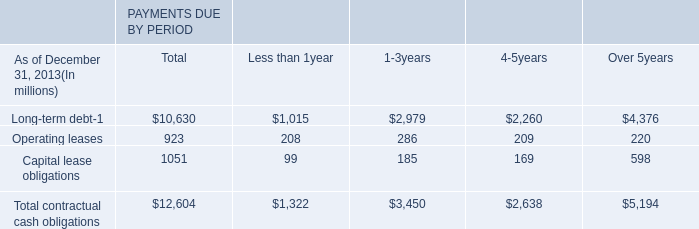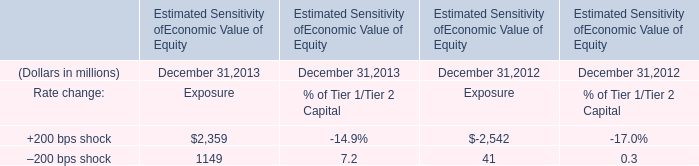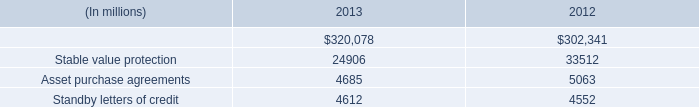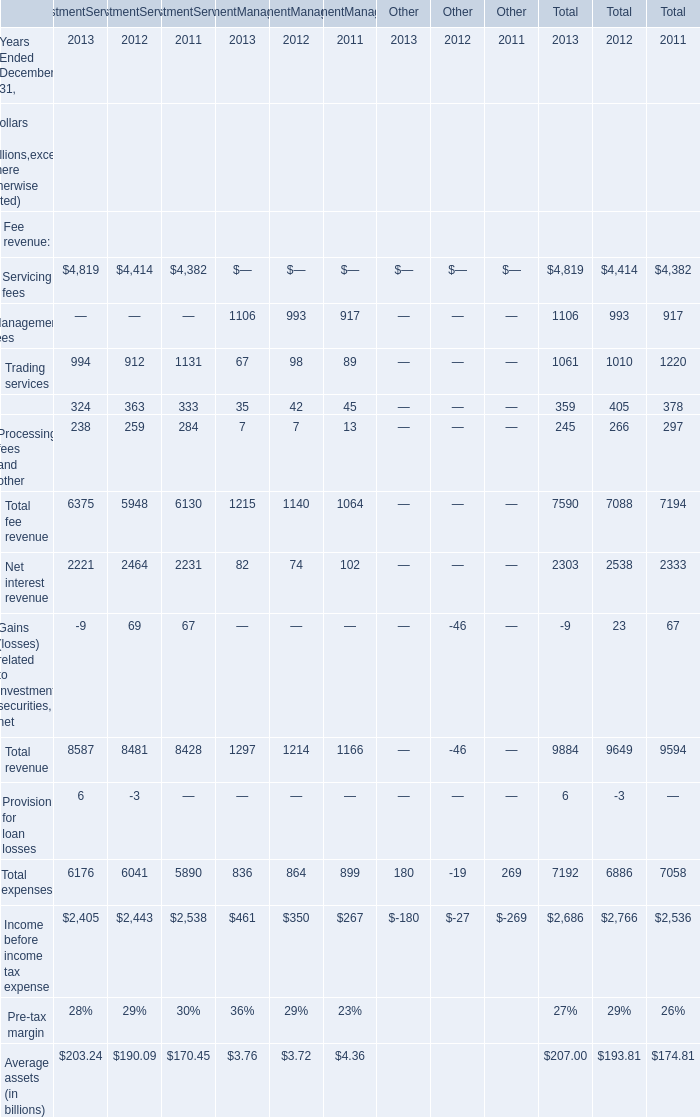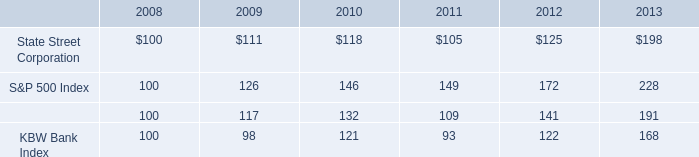what is the percentage change in the balance of asset purchase agreements from 2012 to 2013? 
Computations: ((4685 - 5063) / 5063)
Answer: -0.07466. 